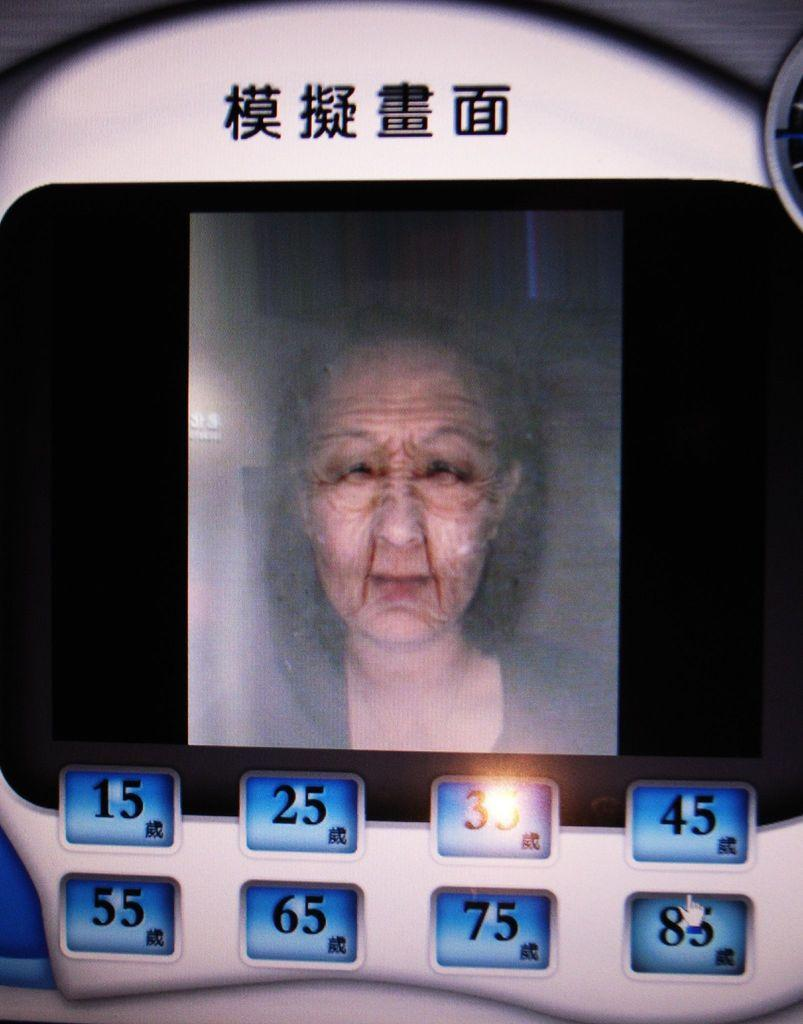What is the main object in the image? There is a screen in the image. What can be seen on the screen? The screen displays an image of a person. Are there any interactive elements on the screen? Yes, there are buttons visible on the screen. What else can be found on the screen besides the image and buttons? There is text present on the screen. Can you see a trail of lipstick on the screen in the image? There is no trail of lipstick present on the screen in the image. 